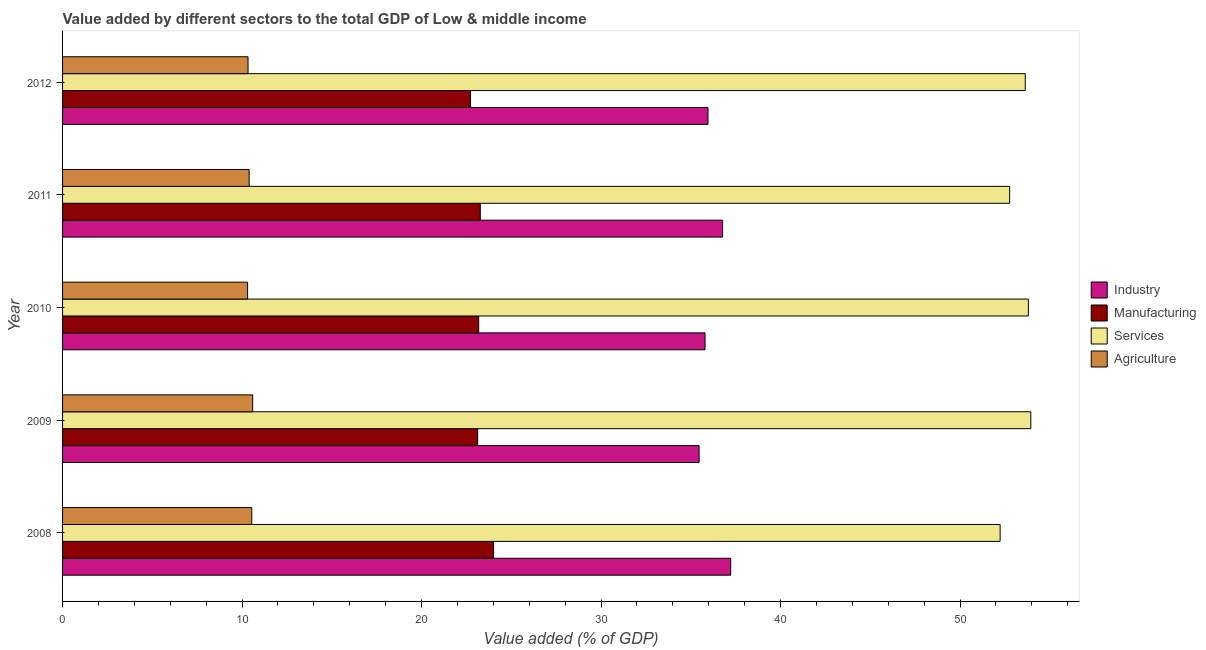How many different coloured bars are there?
Make the answer very short. 4. How many groups of bars are there?
Offer a terse response. 5. Are the number of bars per tick equal to the number of legend labels?
Provide a succinct answer. Yes. What is the value added by services sector in 2012?
Provide a succinct answer. 53.63. Across all years, what is the maximum value added by manufacturing sector?
Give a very brief answer. 24.01. Across all years, what is the minimum value added by industrial sector?
Make the answer very short. 35.46. In which year was the value added by services sector maximum?
Your response must be concise. 2009. In which year was the value added by manufacturing sector minimum?
Your answer should be compact. 2012. What is the total value added by industrial sector in the graph?
Keep it short and to the point. 181.21. What is the difference between the value added by industrial sector in 2009 and that in 2012?
Give a very brief answer. -0.49. What is the difference between the value added by services sector in 2009 and the value added by agricultural sector in 2011?
Offer a very short reply. 43.55. What is the average value added by agricultural sector per year?
Offer a terse response. 10.43. In the year 2009, what is the difference between the value added by services sector and value added by manufacturing sector?
Make the answer very short. 30.82. What is the ratio of the value added by manufacturing sector in 2009 to that in 2011?
Ensure brevity in your answer.  0.99. Is the value added by manufacturing sector in 2008 less than that in 2009?
Your answer should be compact. No. What is the difference between the highest and the second highest value added by manufacturing sector?
Offer a terse response. 0.74. What is the difference between the highest and the lowest value added by industrial sector?
Provide a short and direct response. 1.76. What does the 4th bar from the top in 2008 represents?
Ensure brevity in your answer.  Industry. What does the 4th bar from the bottom in 2008 represents?
Your response must be concise. Agriculture. Is it the case that in every year, the sum of the value added by industrial sector and value added by manufacturing sector is greater than the value added by services sector?
Your response must be concise. Yes. How many years are there in the graph?
Offer a terse response. 5. What is the difference between two consecutive major ticks on the X-axis?
Provide a succinct answer. 10. Does the graph contain any zero values?
Provide a succinct answer. No. Where does the legend appear in the graph?
Make the answer very short. Center right. How many legend labels are there?
Make the answer very short. 4. How are the legend labels stacked?
Offer a very short reply. Vertical. What is the title of the graph?
Keep it short and to the point. Value added by different sectors to the total GDP of Low & middle income. Does "Financial sector" appear as one of the legend labels in the graph?
Provide a short and direct response. No. What is the label or title of the X-axis?
Your response must be concise. Value added (% of GDP). What is the label or title of the Y-axis?
Make the answer very short. Year. What is the Value added (% of GDP) in Industry in 2008?
Ensure brevity in your answer.  37.22. What is the Value added (% of GDP) in Manufacturing in 2008?
Keep it short and to the point. 24.01. What is the Value added (% of GDP) in Services in 2008?
Keep it short and to the point. 52.23. What is the Value added (% of GDP) in Agriculture in 2008?
Your response must be concise. 10.54. What is the Value added (% of GDP) of Industry in 2009?
Offer a very short reply. 35.46. What is the Value added (% of GDP) in Manufacturing in 2009?
Ensure brevity in your answer.  23.13. What is the Value added (% of GDP) of Services in 2009?
Keep it short and to the point. 53.94. What is the Value added (% of GDP) in Agriculture in 2009?
Your answer should be very brief. 10.59. What is the Value added (% of GDP) in Industry in 2010?
Keep it short and to the point. 35.79. What is the Value added (% of GDP) of Manufacturing in 2010?
Keep it short and to the point. 23.18. What is the Value added (% of GDP) in Services in 2010?
Ensure brevity in your answer.  53.81. What is the Value added (% of GDP) of Agriculture in 2010?
Ensure brevity in your answer.  10.31. What is the Value added (% of GDP) of Industry in 2011?
Your answer should be very brief. 36.77. What is the Value added (% of GDP) of Manufacturing in 2011?
Provide a short and direct response. 23.27. What is the Value added (% of GDP) in Services in 2011?
Offer a very short reply. 52.76. What is the Value added (% of GDP) of Agriculture in 2011?
Keep it short and to the point. 10.39. What is the Value added (% of GDP) of Industry in 2012?
Your response must be concise. 35.96. What is the Value added (% of GDP) of Manufacturing in 2012?
Offer a very short reply. 22.73. What is the Value added (% of GDP) of Services in 2012?
Provide a short and direct response. 53.63. What is the Value added (% of GDP) of Agriculture in 2012?
Offer a terse response. 10.33. Across all years, what is the maximum Value added (% of GDP) of Industry?
Offer a terse response. 37.22. Across all years, what is the maximum Value added (% of GDP) of Manufacturing?
Provide a succinct answer. 24.01. Across all years, what is the maximum Value added (% of GDP) in Services?
Your answer should be very brief. 53.94. Across all years, what is the maximum Value added (% of GDP) in Agriculture?
Your response must be concise. 10.59. Across all years, what is the minimum Value added (% of GDP) in Industry?
Provide a succinct answer. 35.46. Across all years, what is the minimum Value added (% of GDP) of Manufacturing?
Provide a short and direct response. 22.73. Across all years, what is the minimum Value added (% of GDP) in Services?
Your answer should be very brief. 52.23. Across all years, what is the minimum Value added (% of GDP) in Agriculture?
Provide a short and direct response. 10.31. What is the total Value added (% of GDP) of Industry in the graph?
Your answer should be compact. 181.21. What is the total Value added (% of GDP) of Manufacturing in the graph?
Give a very brief answer. 116.32. What is the total Value added (% of GDP) of Services in the graph?
Offer a terse response. 266.38. What is the total Value added (% of GDP) in Agriculture in the graph?
Offer a terse response. 52.17. What is the difference between the Value added (% of GDP) of Industry in 2008 and that in 2009?
Give a very brief answer. 1.76. What is the difference between the Value added (% of GDP) in Manufacturing in 2008 and that in 2009?
Ensure brevity in your answer.  0.89. What is the difference between the Value added (% of GDP) in Services in 2008 and that in 2009?
Keep it short and to the point. -1.71. What is the difference between the Value added (% of GDP) of Agriculture in 2008 and that in 2009?
Make the answer very short. -0.05. What is the difference between the Value added (% of GDP) of Industry in 2008 and that in 2010?
Ensure brevity in your answer.  1.43. What is the difference between the Value added (% of GDP) in Manufacturing in 2008 and that in 2010?
Offer a very short reply. 0.83. What is the difference between the Value added (% of GDP) in Services in 2008 and that in 2010?
Provide a short and direct response. -1.57. What is the difference between the Value added (% of GDP) of Agriculture in 2008 and that in 2010?
Offer a very short reply. 0.23. What is the difference between the Value added (% of GDP) in Industry in 2008 and that in 2011?
Offer a very short reply. 0.45. What is the difference between the Value added (% of GDP) in Manufacturing in 2008 and that in 2011?
Keep it short and to the point. 0.74. What is the difference between the Value added (% of GDP) in Services in 2008 and that in 2011?
Make the answer very short. -0.53. What is the difference between the Value added (% of GDP) in Agriculture in 2008 and that in 2011?
Your answer should be compact. 0.15. What is the difference between the Value added (% of GDP) of Industry in 2008 and that in 2012?
Your answer should be very brief. 1.27. What is the difference between the Value added (% of GDP) of Manufacturing in 2008 and that in 2012?
Offer a terse response. 1.29. What is the difference between the Value added (% of GDP) in Services in 2008 and that in 2012?
Keep it short and to the point. -1.4. What is the difference between the Value added (% of GDP) in Agriculture in 2008 and that in 2012?
Offer a terse response. 0.21. What is the difference between the Value added (% of GDP) of Industry in 2009 and that in 2010?
Make the answer very short. -0.33. What is the difference between the Value added (% of GDP) of Manufacturing in 2009 and that in 2010?
Provide a short and direct response. -0.06. What is the difference between the Value added (% of GDP) of Services in 2009 and that in 2010?
Give a very brief answer. 0.14. What is the difference between the Value added (% of GDP) in Agriculture in 2009 and that in 2010?
Your answer should be very brief. 0.28. What is the difference between the Value added (% of GDP) in Industry in 2009 and that in 2011?
Make the answer very short. -1.31. What is the difference between the Value added (% of GDP) of Manufacturing in 2009 and that in 2011?
Provide a short and direct response. -0.15. What is the difference between the Value added (% of GDP) of Services in 2009 and that in 2011?
Make the answer very short. 1.18. What is the difference between the Value added (% of GDP) of Agriculture in 2009 and that in 2011?
Provide a short and direct response. 0.2. What is the difference between the Value added (% of GDP) in Industry in 2009 and that in 2012?
Give a very brief answer. -0.49. What is the difference between the Value added (% of GDP) of Manufacturing in 2009 and that in 2012?
Offer a very short reply. 0.4. What is the difference between the Value added (% of GDP) of Services in 2009 and that in 2012?
Provide a short and direct response. 0.31. What is the difference between the Value added (% of GDP) of Agriculture in 2009 and that in 2012?
Provide a succinct answer. 0.26. What is the difference between the Value added (% of GDP) of Industry in 2010 and that in 2011?
Offer a very short reply. -0.98. What is the difference between the Value added (% of GDP) in Manufacturing in 2010 and that in 2011?
Make the answer very short. -0.09. What is the difference between the Value added (% of GDP) of Services in 2010 and that in 2011?
Offer a terse response. 1.04. What is the difference between the Value added (% of GDP) of Agriculture in 2010 and that in 2011?
Your response must be concise. -0.09. What is the difference between the Value added (% of GDP) in Industry in 2010 and that in 2012?
Your answer should be compact. -0.16. What is the difference between the Value added (% of GDP) of Manufacturing in 2010 and that in 2012?
Make the answer very short. 0.46. What is the difference between the Value added (% of GDP) of Services in 2010 and that in 2012?
Offer a very short reply. 0.17. What is the difference between the Value added (% of GDP) in Agriculture in 2010 and that in 2012?
Your answer should be compact. -0.02. What is the difference between the Value added (% of GDP) of Industry in 2011 and that in 2012?
Your answer should be very brief. 0.81. What is the difference between the Value added (% of GDP) in Manufacturing in 2011 and that in 2012?
Ensure brevity in your answer.  0.55. What is the difference between the Value added (% of GDP) in Services in 2011 and that in 2012?
Your answer should be compact. -0.87. What is the difference between the Value added (% of GDP) of Agriculture in 2011 and that in 2012?
Offer a terse response. 0.06. What is the difference between the Value added (% of GDP) in Industry in 2008 and the Value added (% of GDP) in Manufacturing in 2009?
Provide a short and direct response. 14.1. What is the difference between the Value added (% of GDP) in Industry in 2008 and the Value added (% of GDP) in Services in 2009?
Offer a very short reply. -16.72. What is the difference between the Value added (% of GDP) of Industry in 2008 and the Value added (% of GDP) of Agriculture in 2009?
Provide a succinct answer. 26.63. What is the difference between the Value added (% of GDP) of Manufacturing in 2008 and the Value added (% of GDP) of Services in 2009?
Make the answer very short. -29.93. What is the difference between the Value added (% of GDP) in Manufacturing in 2008 and the Value added (% of GDP) in Agriculture in 2009?
Offer a terse response. 13.42. What is the difference between the Value added (% of GDP) of Services in 2008 and the Value added (% of GDP) of Agriculture in 2009?
Make the answer very short. 41.64. What is the difference between the Value added (% of GDP) of Industry in 2008 and the Value added (% of GDP) of Manufacturing in 2010?
Provide a succinct answer. 14.04. What is the difference between the Value added (% of GDP) of Industry in 2008 and the Value added (% of GDP) of Services in 2010?
Provide a succinct answer. -16.58. What is the difference between the Value added (% of GDP) of Industry in 2008 and the Value added (% of GDP) of Agriculture in 2010?
Give a very brief answer. 26.92. What is the difference between the Value added (% of GDP) in Manufacturing in 2008 and the Value added (% of GDP) in Services in 2010?
Provide a short and direct response. -29.79. What is the difference between the Value added (% of GDP) of Manufacturing in 2008 and the Value added (% of GDP) of Agriculture in 2010?
Your response must be concise. 13.71. What is the difference between the Value added (% of GDP) in Services in 2008 and the Value added (% of GDP) in Agriculture in 2010?
Your answer should be compact. 41.93. What is the difference between the Value added (% of GDP) of Industry in 2008 and the Value added (% of GDP) of Manufacturing in 2011?
Your response must be concise. 13.95. What is the difference between the Value added (% of GDP) of Industry in 2008 and the Value added (% of GDP) of Services in 2011?
Provide a short and direct response. -15.54. What is the difference between the Value added (% of GDP) in Industry in 2008 and the Value added (% of GDP) in Agriculture in 2011?
Give a very brief answer. 26.83. What is the difference between the Value added (% of GDP) in Manufacturing in 2008 and the Value added (% of GDP) in Services in 2011?
Your response must be concise. -28.75. What is the difference between the Value added (% of GDP) in Manufacturing in 2008 and the Value added (% of GDP) in Agriculture in 2011?
Provide a short and direct response. 13.62. What is the difference between the Value added (% of GDP) of Services in 2008 and the Value added (% of GDP) of Agriculture in 2011?
Offer a terse response. 41.84. What is the difference between the Value added (% of GDP) in Industry in 2008 and the Value added (% of GDP) in Manufacturing in 2012?
Keep it short and to the point. 14.5. What is the difference between the Value added (% of GDP) of Industry in 2008 and the Value added (% of GDP) of Services in 2012?
Provide a short and direct response. -16.41. What is the difference between the Value added (% of GDP) in Industry in 2008 and the Value added (% of GDP) in Agriculture in 2012?
Your response must be concise. 26.89. What is the difference between the Value added (% of GDP) of Manufacturing in 2008 and the Value added (% of GDP) of Services in 2012?
Keep it short and to the point. -29.62. What is the difference between the Value added (% of GDP) of Manufacturing in 2008 and the Value added (% of GDP) of Agriculture in 2012?
Provide a succinct answer. 13.68. What is the difference between the Value added (% of GDP) of Services in 2008 and the Value added (% of GDP) of Agriculture in 2012?
Offer a very short reply. 41.9. What is the difference between the Value added (% of GDP) in Industry in 2009 and the Value added (% of GDP) in Manufacturing in 2010?
Make the answer very short. 12.28. What is the difference between the Value added (% of GDP) in Industry in 2009 and the Value added (% of GDP) in Services in 2010?
Your response must be concise. -18.34. What is the difference between the Value added (% of GDP) of Industry in 2009 and the Value added (% of GDP) of Agriculture in 2010?
Your answer should be compact. 25.15. What is the difference between the Value added (% of GDP) of Manufacturing in 2009 and the Value added (% of GDP) of Services in 2010?
Your answer should be compact. -30.68. What is the difference between the Value added (% of GDP) of Manufacturing in 2009 and the Value added (% of GDP) of Agriculture in 2010?
Give a very brief answer. 12.82. What is the difference between the Value added (% of GDP) of Services in 2009 and the Value added (% of GDP) of Agriculture in 2010?
Offer a terse response. 43.63. What is the difference between the Value added (% of GDP) in Industry in 2009 and the Value added (% of GDP) in Manufacturing in 2011?
Offer a terse response. 12.19. What is the difference between the Value added (% of GDP) in Industry in 2009 and the Value added (% of GDP) in Services in 2011?
Your answer should be very brief. -17.3. What is the difference between the Value added (% of GDP) in Industry in 2009 and the Value added (% of GDP) in Agriculture in 2011?
Your response must be concise. 25.07. What is the difference between the Value added (% of GDP) in Manufacturing in 2009 and the Value added (% of GDP) in Services in 2011?
Your response must be concise. -29.64. What is the difference between the Value added (% of GDP) of Manufacturing in 2009 and the Value added (% of GDP) of Agriculture in 2011?
Keep it short and to the point. 12.73. What is the difference between the Value added (% of GDP) in Services in 2009 and the Value added (% of GDP) in Agriculture in 2011?
Offer a very short reply. 43.55. What is the difference between the Value added (% of GDP) in Industry in 2009 and the Value added (% of GDP) in Manufacturing in 2012?
Offer a very short reply. 12.74. What is the difference between the Value added (% of GDP) in Industry in 2009 and the Value added (% of GDP) in Services in 2012?
Provide a short and direct response. -18.17. What is the difference between the Value added (% of GDP) in Industry in 2009 and the Value added (% of GDP) in Agriculture in 2012?
Provide a succinct answer. 25.13. What is the difference between the Value added (% of GDP) of Manufacturing in 2009 and the Value added (% of GDP) of Services in 2012?
Offer a terse response. -30.51. What is the difference between the Value added (% of GDP) of Manufacturing in 2009 and the Value added (% of GDP) of Agriculture in 2012?
Offer a very short reply. 12.79. What is the difference between the Value added (% of GDP) in Services in 2009 and the Value added (% of GDP) in Agriculture in 2012?
Give a very brief answer. 43.61. What is the difference between the Value added (% of GDP) of Industry in 2010 and the Value added (% of GDP) of Manufacturing in 2011?
Offer a very short reply. 12.52. What is the difference between the Value added (% of GDP) of Industry in 2010 and the Value added (% of GDP) of Services in 2011?
Make the answer very short. -16.97. What is the difference between the Value added (% of GDP) of Industry in 2010 and the Value added (% of GDP) of Agriculture in 2011?
Provide a short and direct response. 25.4. What is the difference between the Value added (% of GDP) of Manufacturing in 2010 and the Value added (% of GDP) of Services in 2011?
Provide a short and direct response. -29.58. What is the difference between the Value added (% of GDP) of Manufacturing in 2010 and the Value added (% of GDP) of Agriculture in 2011?
Make the answer very short. 12.79. What is the difference between the Value added (% of GDP) of Services in 2010 and the Value added (% of GDP) of Agriculture in 2011?
Your response must be concise. 43.41. What is the difference between the Value added (% of GDP) of Industry in 2010 and the Value added (% of GDP) of Manufacturing in 2012?
Ensure brevity in your answer.  13.07. What is the difference between the Value added (% of GDP) in Industry in 2010 and the Value added (% of GDP) in Services in 2012?
Your answer should be very brief. -17.84. What is the difference between the Value added (% of GDP) in Industry in 2010 and the Value added (% of GDP) in Agriculture in 2012?
Make the answer very short. 25.46. What is the difference between the Value added (% of GDP) in Manufacturing in 2010 and the Value added (% of GDP) in Services in 2012?
Give a very brief answer. -30.45. What is the difference between the Value added (% of GDP) of Manufacturing in 2010 and the Value added (% of GDP) of Agriculture in 2012?
Your answer should be very brief. 12.85. What is the difference between the Value added (% of GDP) of Services in 2010 and the Value added (% of GDP) of Agriculture in 2012?
Keep it short and to the point. 43.47. What is the difference between the Value added (% of GDP) of Industry in 2011 and the Value added (% of GDP) of Manufacturing in 2012?
Your answer should be very brief. 14.05. What is the difference between the Value added (% of GDP) of Industry in 2011 and the Value added (% of GDP) of Services in 2012?
Make the answer very short. -16.86. What is the difference between the Value added (% of GDP) of Industry in 2011 and the Value added (% of GDP) of Agriculture in 2012?
Make the answer very short. 26.44. What is the difference between the Value added (% of GDP) in Manufacturing in 2011 and the Value added (% of GDP) in Services in 2012?
Make the answer very short. -30.36. What is the difference between the Value added (% of GDP) in Manufacturing in 2011 and the Value added (% of GDP) in Agriculture in 2012?
Your answer should be very brief. 12.94. What is the difference between the Value added (% of GDP) of Services in 2011 and the Value added (% of GDP) of Agriculture in 2012?
Offer a very short reply. 42.43. What is the average Value added (% of GDP) of Industry per year?
Offer a terse response. 36.24. What is the average Value added (% of GDP) of Manufacturing per year?
Offer a terse response. 23.26. What is the average Value added (% of GDP) in Services per year?
Make the answer very short. 53.28. What is the average Value added (% of GDP) of Agriculture per year?
Give a very brief answer. 10.43. In the year 2008, what is the difference between the Value added (% of GDP) of Industry and Value added (% of GDP) of Manufacturing?
Offer a very short reply. 13.21. In the year 2008, what is the difference between the Value added (% of GDP) in Industry and Value added (% of GDP) in Services?
Provide a short and direct response. -15.01. In the year 2008, what is the difference between the Value added (% of GDP) in Industry and Value added (% of GDP) in Agriculture?
Provide a succinct answer. 26.68. In the year 2008, what is the difference between the Value added (% of GDP) of Manufacturing and Value added (% of GDP) of Services?
Offer a very short reply. -28.22. In the year 2008, what is the difference between the Value added (% of GDP) in Manufacturing and Value added (% of GDP) in Agriculture?
Provide a succinct answer. 13.47. In the year 2008, what is the difference between the Value added (% of GDP) of Services and Value added (% of GDP) of Agriculture?
Your answer should be compact. 41.7. In the year 2009, what is the difference between the Value added (% of GDP) in Industry and Value added (% of GDP) in Manufacturing?
Offer a terse response. 12.34. In the year 2009, what is the difference between the Value added (% of GDP) in Industry and Value added (% of GDP) in Services?
Your response must be concise. -18.48. In the year 2009, what is the difference between the Value added (% of GDP) of Industry and Value added (% of GDP) of Agriculture?
Make the answer very short. 24.87. In the year 2009, what is the difference between the Value added (% of GDP) of Manufacturing and Value added (% of GDP) of Services?
Provide a short and direct response. -30.82. In the year 2009, what is the difference between the Value added (% of GDP) in Manufacturing and Value added (% of GDP) in Agriculture?
Ensure brevity in your answer.  12.53. In the year 2009, what is the difference between the Value added (% of GDP) in Services and Value added (% of GDP) in Agriculture?
Provide a succinct answer. 43.35. In the year 2010, what is the difference between the Value added (% of GDP) in Industry and Value added (% of GDP) in Manufacturing?
Ensure brevity in your answer.  12.61. In the year 2010, what is the difference between the Value added (% of GDP) in Industry and Value added (% of GDP) in Services?
Keep it short and to the point. -18.01. In the year 2010, what is the difference between the Value added (% of GDP) in Industry and Value added (% of GDP) in Agriculture?
Provide a succinct answer. 25.48. In the year 2010, what is the difference between the Value added (% of GDP) in Manufacturing and Value added (% of GDP) in Services?
Your answer should be very brief. -30.62. In the year 2010, what is the difference between the Value added (% of GDP) of Manufacturing and Value added (% of GDP) of Agriculture?
Provide a short and direct response. 12.87. In the year 2010, what is the difference between the Value added (% of GDP) in Services and Value added (% of GDP) in Agriculture?
Provide a short and direct response. 43.5. In the year 2011, what is the difference between the Value added (% of GDP) in Industry and Value added (% of GDP) in Manufacturing?
Your response must be concise. 13.5. In the year 2011, what is the difference between the Value added (% of GDP) in Industry and Value added (% of GDP) in Services?
Offer a very short reply. -15.99. In the year 2011, what is the difference between the Value added (% of GDP) in Industry and Value added (% of GDP) in Agriculture?
Offer a terse response. 26.38. In the year 2011, what is the difference between the Value added (% of GDP) of Manufacturing and Value added (% of GDP) of Services?
Provide a succinct answer. -29.49. In the year 2011, what is the difference between the Value added (% of GDP) in Manufacturing and Value added (% of GDP) in Agriculture?
Make the answer very short. 12.88. In the year 2011, what is the difference between the Value added (% of GDP) of Services and Value added (% of GDP) of Agriculture?
Ensure brevity in your answer.  42.37. In the year 2012, what is the difference between the Value added (% of GDP) in Industry and Value added (% of GDP) in Manufacturing?
Make the answer very short. 13.23. In the year 2012, what is the difference between the Value added (% of GDP) of Industry and Value added (% of GDP) of Services?
Ensure brevity in your answer.  -17.68. In the year 2012, what is the difference between the Value added (% of GDP) of Industry and Value added (% of GDP) of Agriculture?
Make the answer very short. 25.62. In the year 2012, what is the difference between the Value added (% of GDP) in Manufacturing and Value added (% of GDP) in Services?
Offer a very short reply. -30.91. In the year 2012, what is the difference between the Value added (% of GDP) in Manufacturing and Value added (% of GDP) in Agriculture?
Keep it short and to the point. 12.39. In the year 2012, what is the difference between the Value added (% of GDP) in Services and Value added (% of GDP) in Agriculture?
Make the answer very short. 43.3. What is the ratio of the Value added (% of GDP) of Industry in 2008 to that in 2009?
Your answer should be compact. 1.05. What is the ratio of the Value added (% of GDP) in Manufacturing in 2008 to that in 2009?
Ensure brevity in your answer.  1.04. What is the ratio of the Value added (% of GDP) of Services in 2008 to that in 2009?
Offer a terse response. 0.97. What is the ratio of the Value added (% of GDP) in Industry in 2008 to that in 2010?
Make the answer very short. 1.04. What is the ratio of the Value added (% of GDP) in Manufacturing in 2008 to that in 2010?
Keep it short and to the point. 1.04. What is the ratio of the Value added (% of GDP) of Services in 2008 to that in 2010?
Ensure brevity in your answer.  0.97. What is the ratio of the Value added (% of GDP) in Agriculture in 2008 to that in 2010?
Your answer should be compact. 1.02. What is the ratio of the Value added (% of GDP) of Industry in 2008 to that in 2011?
Offer a very short reply. 1.01. What is the ratio of the Value added (% of GDP) of Manufacturing in 2008 to that in 2011?
Give a very brief answer. 1.03. What is the ratio of the Value added (% of GDP) of Agriculture in 2008 to that in 2011?
Your answer should be very brief. 1.01. What is the ratio of the Value added (% of GDP) in Industry in 2008 to that in 2012?
Make the answer very short. 1.04. What is the ratio of the Value added (% of GDP) of Manufacturing in 2008 to that in 2012?
Provide a short and direct response. 1.06. What is the ratio of the Value added (% of GDP) in Services in 2008 to that in 2012?
Keep it short and to the point. 0.97. What is the ratio of the Value added (% of GDP) of Agriculture in 2008 to that in 2012?
Ensure brevity in your answer.  1.02. What is the ratio of the Value added (% of GDP) in Services in 2009 to that in 2010?
Offer a terse response. 1. What is the ratio of the Value added (% of GDP) in Agriculture in 2009 to that in 2010?
Make the answer very short. 1.03. What is the ratio of the Value added (% of GDP) of Industry in 2009 to that in 2011?
Your response must be concise. 0.96. What is the ratio of the Value added (% of GDP) in Services in 2009 to that in 2011?
Your response must be concise. 1.02. What is the ratio of the Value added (% of GDP) of Agriculture in 2009 to that in 2011?
Offer a very short reply. 1.02. What is the ratio of the Value added (% of GDP) of Industry in 2009 to that in 2012?
Your response must be concise. 0.99. What is the ratio of the Value added (% of GDP) in Manufacturing in 2009 to that in 2012?
Give a very brief answer. 1.02. What is the ratio of the Value added (% of GDP) in Services in 2009 to that in 2012?
Your response must be concise. 1.01. What is the ratio of the Value added (% of GDP) of Agriculture in 2009 to that in 2012?
Offer a terse response. 1.02. What is the ratio of the Value added (% of GDP) of Industry in 2010 to that in 2011?
Ensure brevity in your answer.  0.97. What is the ratio of the Value added (% of GDP) in Services in 2010 to that in 2011?
Your answer should be very brief. 1.02. What is the ratio of the Value added (% of GDP) of Manufacturing in 2010 to that in 2012?
Give a very brief answer. 1.02. What is the ratio of the Value added (% of GDP) of Services in 2010 to that in 2012?
Make the answer very short. 1. What is the ratio of the Value added (% of GDP) of Agriculture in 2010 to that in 2012?
Provide a short and direct response. 1. What is the ratio of the Value added (% of GDP) of Industry in 2011 to that in 2012?
Offer a very short reply. 1.02. What is the ratio of the Value added (% of GDP) in Manufacturing in 2011 to that in 2012?
Your response must be concise. 1.02. What is the ratio of the Value added (% of GDP) of Services in 2011 to that in 2012?
Keep it short and to the point. 0.98. What is the ratio of the Value added (% of GDP) in Agriculture in 2011 to that in 2012?
Give a very brief answer. 1.01. What is the difference between the highest and the second highest Value added (% of GDP) in Industry?
Offer a terse response. 0.45. What is the difference between the highest and the second highest Value added (% of GDP) in Manufacturing?
Your answer should be compact. 0.74. What is the difference between the highest and the second highest Value added (% of GDP) of Services?
Your answer should be compact. 0.14. What is the difference between the highest and the second highest Value added (% of GDP) in Agriculture?
Keep it short and to the point. 0.05. What is the difference between the highest and the lowest Value added (% of GDP) in Industry?
Ensure brevity in your answer.  1.76. What is the difference between the highest and the lowest Value added (% of GDP) in Manufacturing?
Ensure brevity in your answer.  1.29. What is the difference between the highest and the lowest Value added (% of GDP) in Services?
Offer a very short reply. 1.71. What is the difference between the highest and the lowest Value added (% of GDP) in Agriculture?
Make the answer very short. 0.28. 